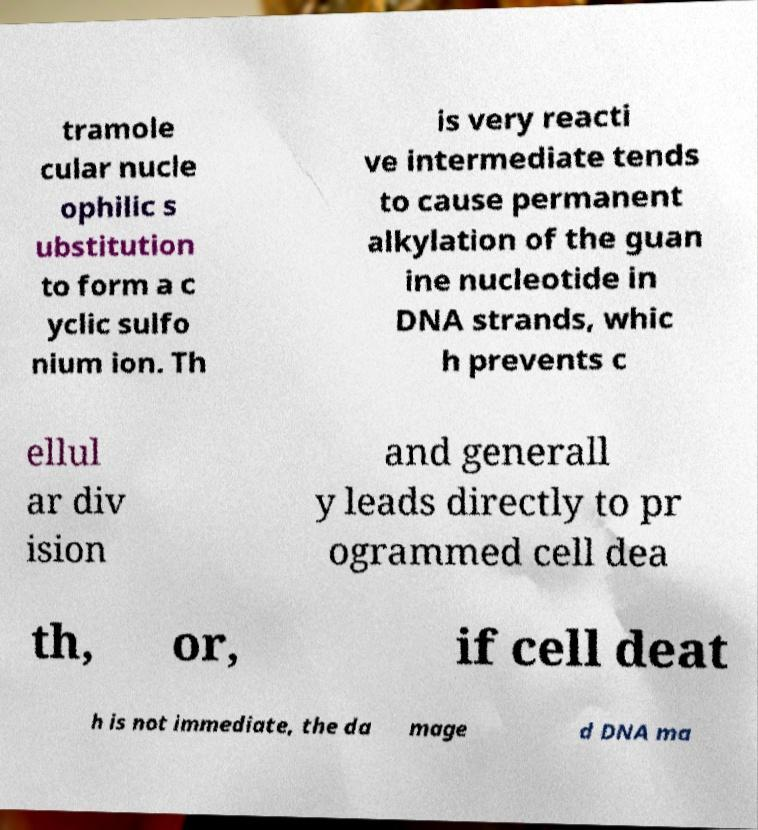There's text embedded in this image that I need extracted. Can you transcribe it verbatim? tramole cular nucle ophilic s ubstitution to form a c yclic sulfo nium ion. Th is very reacti ve intermediate tends to cause permanent alkylation of the guan ine nucleotide in DNA strands, whic h prevents c ellul ar div ision and generall y leads directly to pr ogrammed cell dea th, or, if cell deat h is not immediate, the da mage d DNA ma 